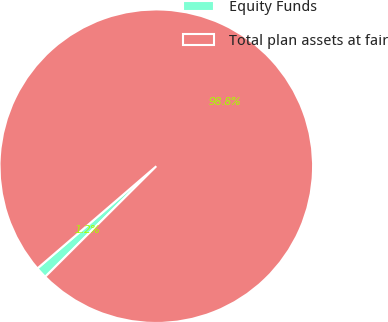Convert chart. <chart><loc_0><loc_0><loc_500><loc_500><pie_chart><fcel>Equity Funds<fcel>Total plan assets at fair<nl><fcel>1.16%<fcel>98.84%<nl></chart> 